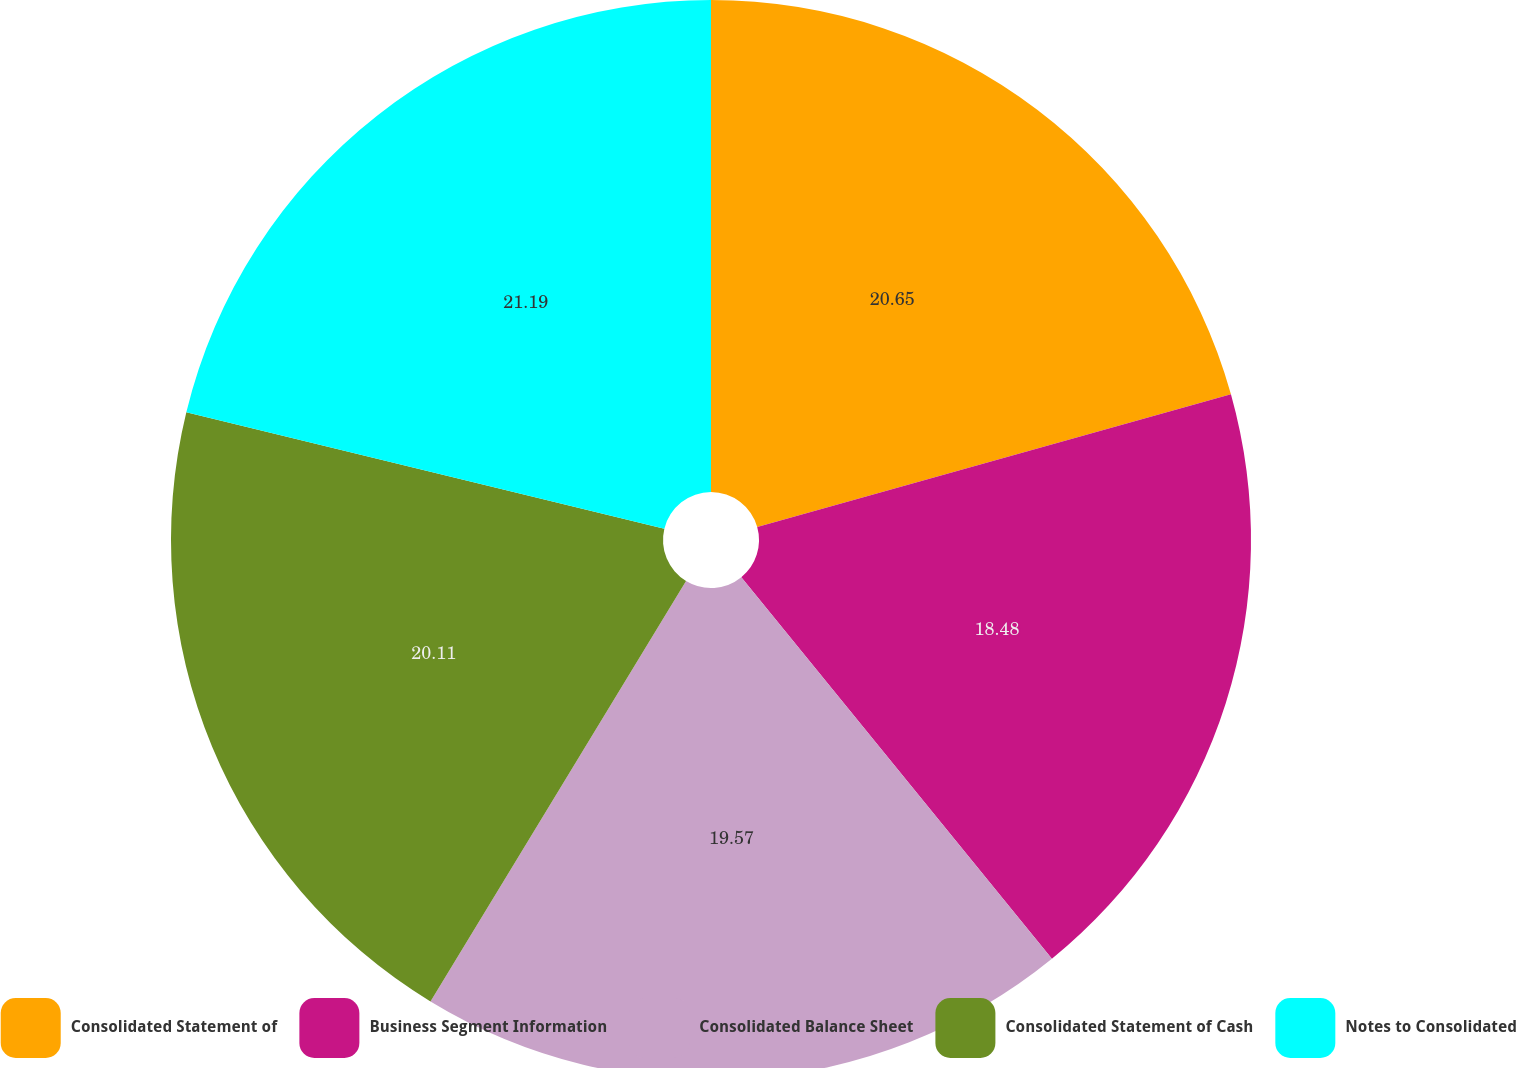Convert chart to OTSL. <chart><loc_0><loc_0><loc_500><loc_500><pie_chart><fcel>Consolidated Statement of<fcel>Business Segment Information<fcel>Consolidated Balance Sheet<fcel>Consolidated Statement of Cash<fcel>Notes to Consolidated<nl><fcel>20.65%<fcel>18.48%<fcel>19.57%<fcel>20.11%<fcel>21.2%<nl></chart> 